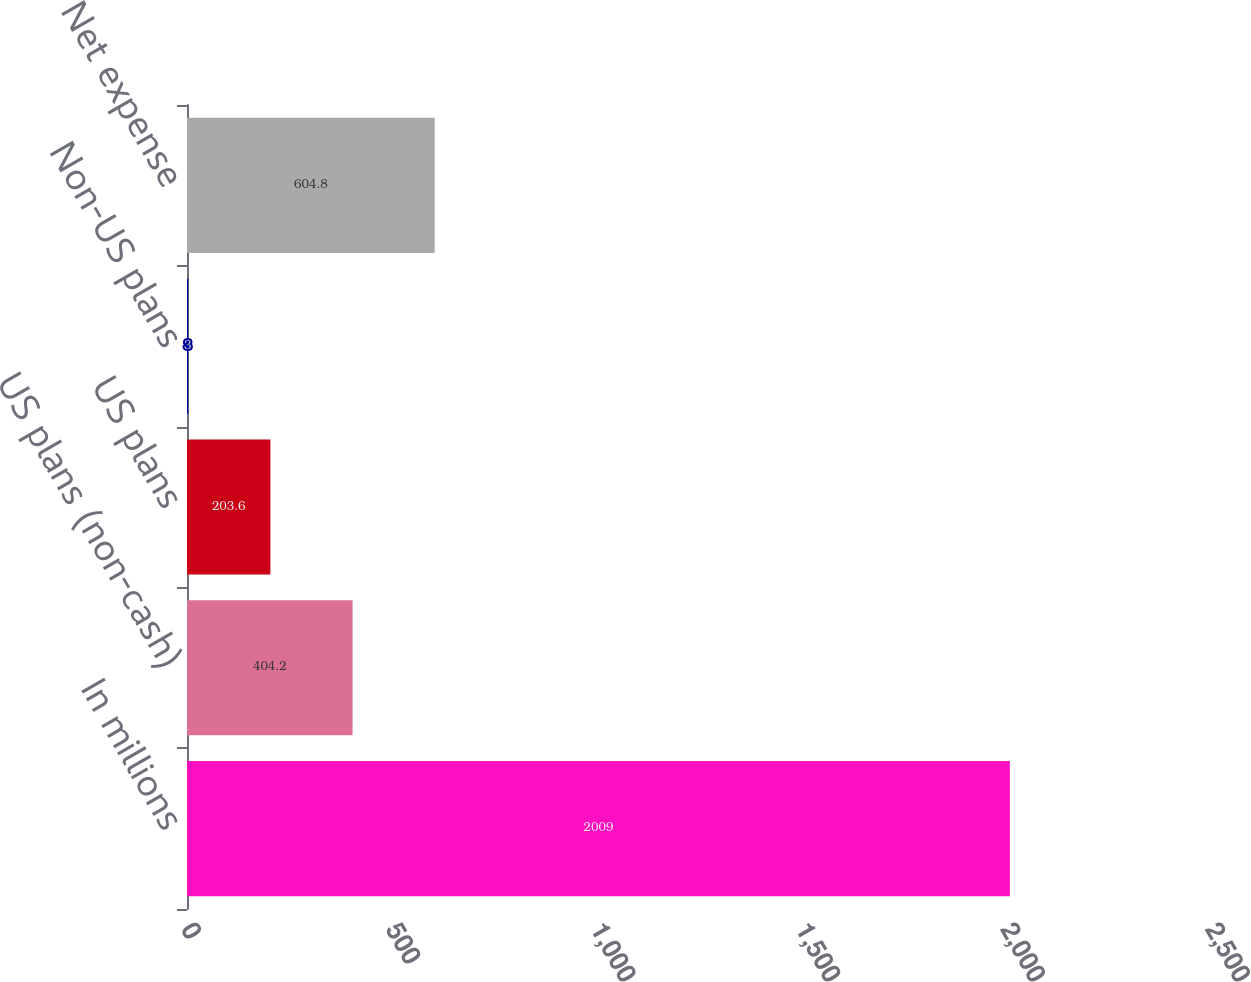Convert chart. <chart><loc_0><loc_0><loc_500><loc_500><bar_chart><fcel>In millions<fcel>US plans (non-cash)<fcel>US plans<fcel>Non-US plans<fcel>Net expense<nl><fcel>2009<fcel>404.2<fcel>203.6<fcel>3<fcel>604.8<nl></chart> 